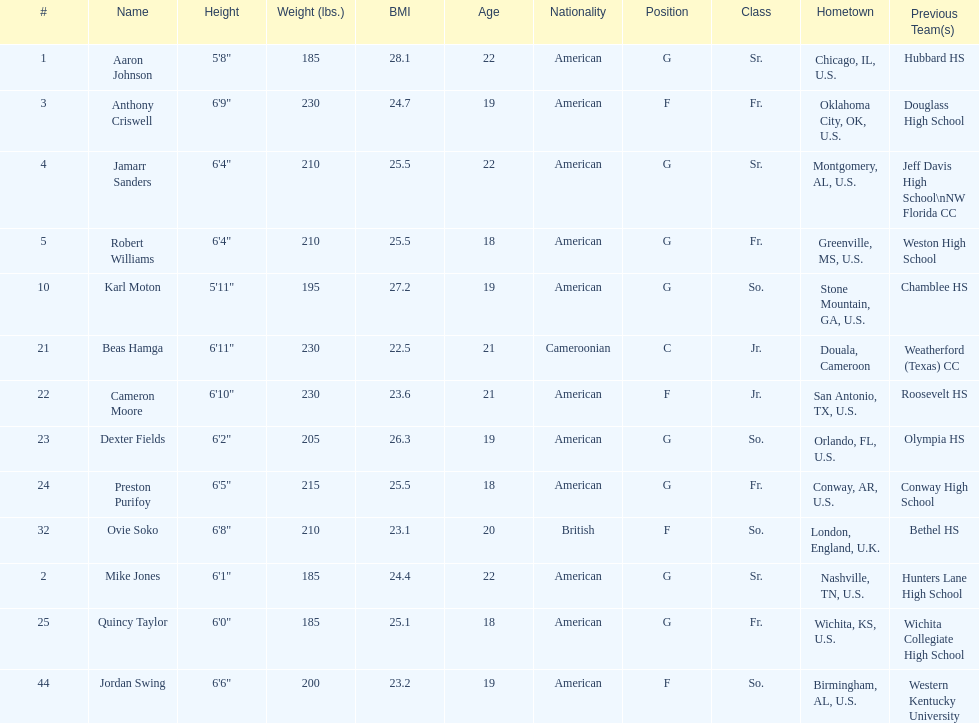What's the total count of forwards on the team? 4. Can you parse all the data within this table? {'header': ['#', 'Name', 'Height', 'Weight (lbs.)', 'BMI', 'Age', 'Nationality', 'Position', 'Class', 'Hometown', 'Previous Team(s)'], 'rows': [['1', 'Aaron Johnson', '5\'8"', '185', '28.1', '22', 'American', 'G', 'Sr.', 'Chicago, IL, U.S.', 'Hubbard HS'], ['3', 'Anthony Criswell', '6\'9"', '230', '24.7', '19', 'American', 'F', 'Fr.', 'Oklahoma City, OK, U.S.', 'Douglass High School'], ['4', 'Jamarr Sanders', '6\'4"', '210', '25.5', '22', 'American', 'G', 'Sr.', 'Montgomery, AL, U.S.', 'Jeff Davis High School\\nNW Florida CC'], ['5', 'Robert Williams', '6\'4"', '210', '25.5', '18', 'American', 'G', 'Fr.', 'Greenville, MS, U.S.', 'Weston High School'], ['10', 'Karl Moton', '5\'11"', '195', '27.2', '19', 'American', 'G', 'So.', 'Stone Mountain, GA, U.S.', 'Chamblee HS'], ['21', 'Beas Hamga', '6\'11"', '230', '22.5', '21', 'Cameroonian', 'C', 'Jr.', 'Douala, Cameroon', 'Weatherford (Texas) CC'], ['22', 'Cameron Moore', '6\'10"', '230', '23.6', '21', 'American', 'F', 'Jr.', 'San Antonio, TX, U.S.', 'Roosevelt HS'], ['23', 'Dexter Fields', '6\'2"', '205', '26.3', '19', 'American', 'G', 'So.', 'Orlando, FL, U.S.', 'Olympia HS'], ['24', 'Preston Purifoy', '6\'5"', '215', '25.5', '18', 'American', 'G', 'Fr.', 'Conway, AR, U.S.', 'Conway High School'], ['32', 'Ovie Soko', '6\'8"', '210', '23.1', '20', 'British', 'F', 'So.', 'London, England, U.K.', 'Bethel HS'], ['2', 'Mike Jones', '6\'1"', '185', '24.4', '22', 'American', 'G', 'Sr.', 'Nashville, TN, U.S.', 'Hunters Lane High School'], ['25', 'Quincy Taylor', '6\'0"', '185', '25.1', '18', 'American', 'G', 'Fr.', 'Wichita, KS, U.S.', 'Wichita Collegiate High School'], ['44', 'Jordan Swing', '6\'6"', '200', '23.2', '19', 'American', 'F', 'So.', 'Birmingham, AL, U.S.', 'Western Kentucky University']]} 